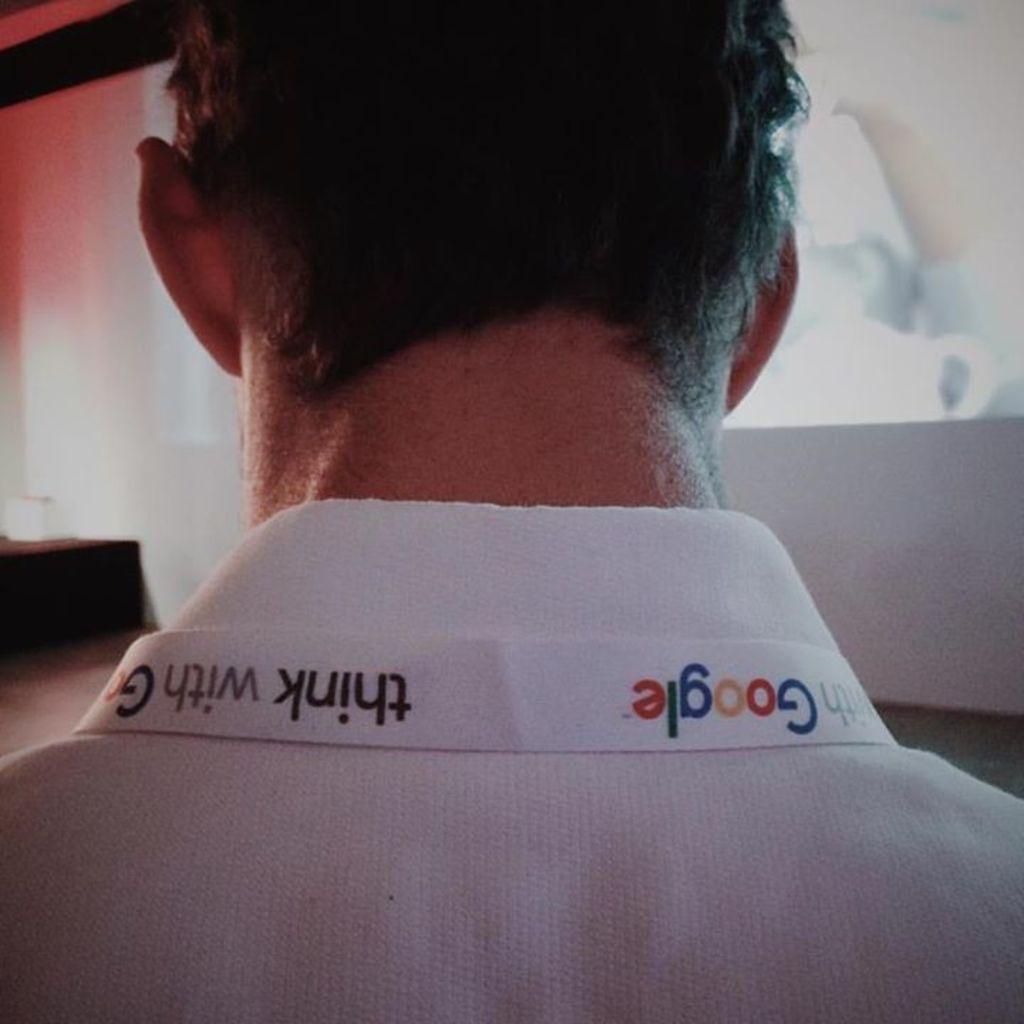Please provide a concise description of this image. In this image I can see a person neck and head and the person wearing a white color shirt on the shirt I can see the text 